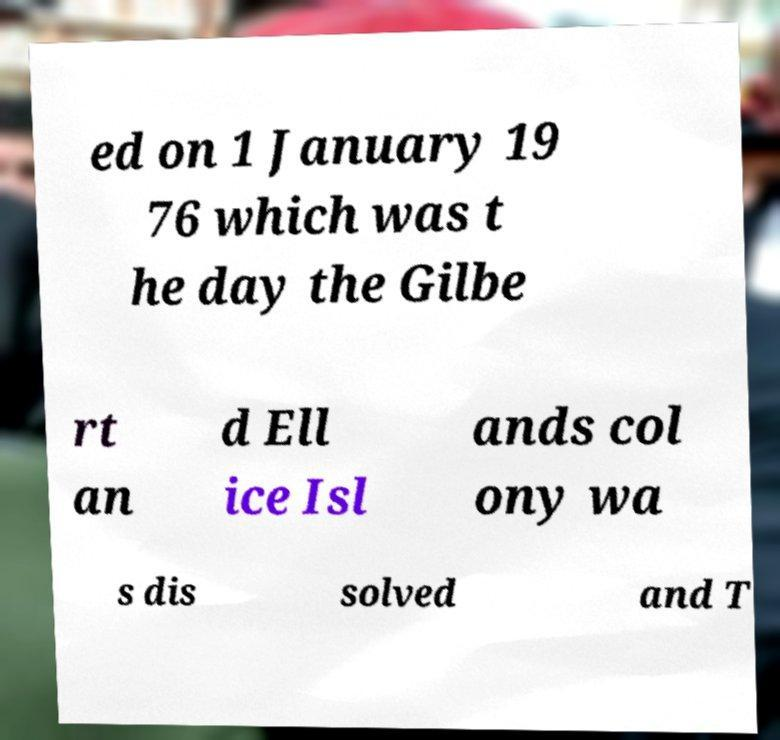Can you read and provide the text displayed in the image?This photo seems to have some interesting text. Can you extract and type it out for me? ed on 1 January 19 76 which was t he day the Gilbe rt an d Ell ice Isl ands col ony wa s dis solved and T 